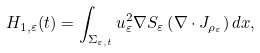Convert formula to latex. <formula><loc_0><loc_0><loc_500><loc_500>H _ { 1 , \varepsilon } ( t ) = \int _ { \Sigma _ { \varepsilon , t } } u _ { \varepsilon } ^ { 2 } \nabla S _ { \varepsilon } \left ( \nabla \cdot J _ { \rho _ { \varepsilon } } \right ) d x ,</formula> 